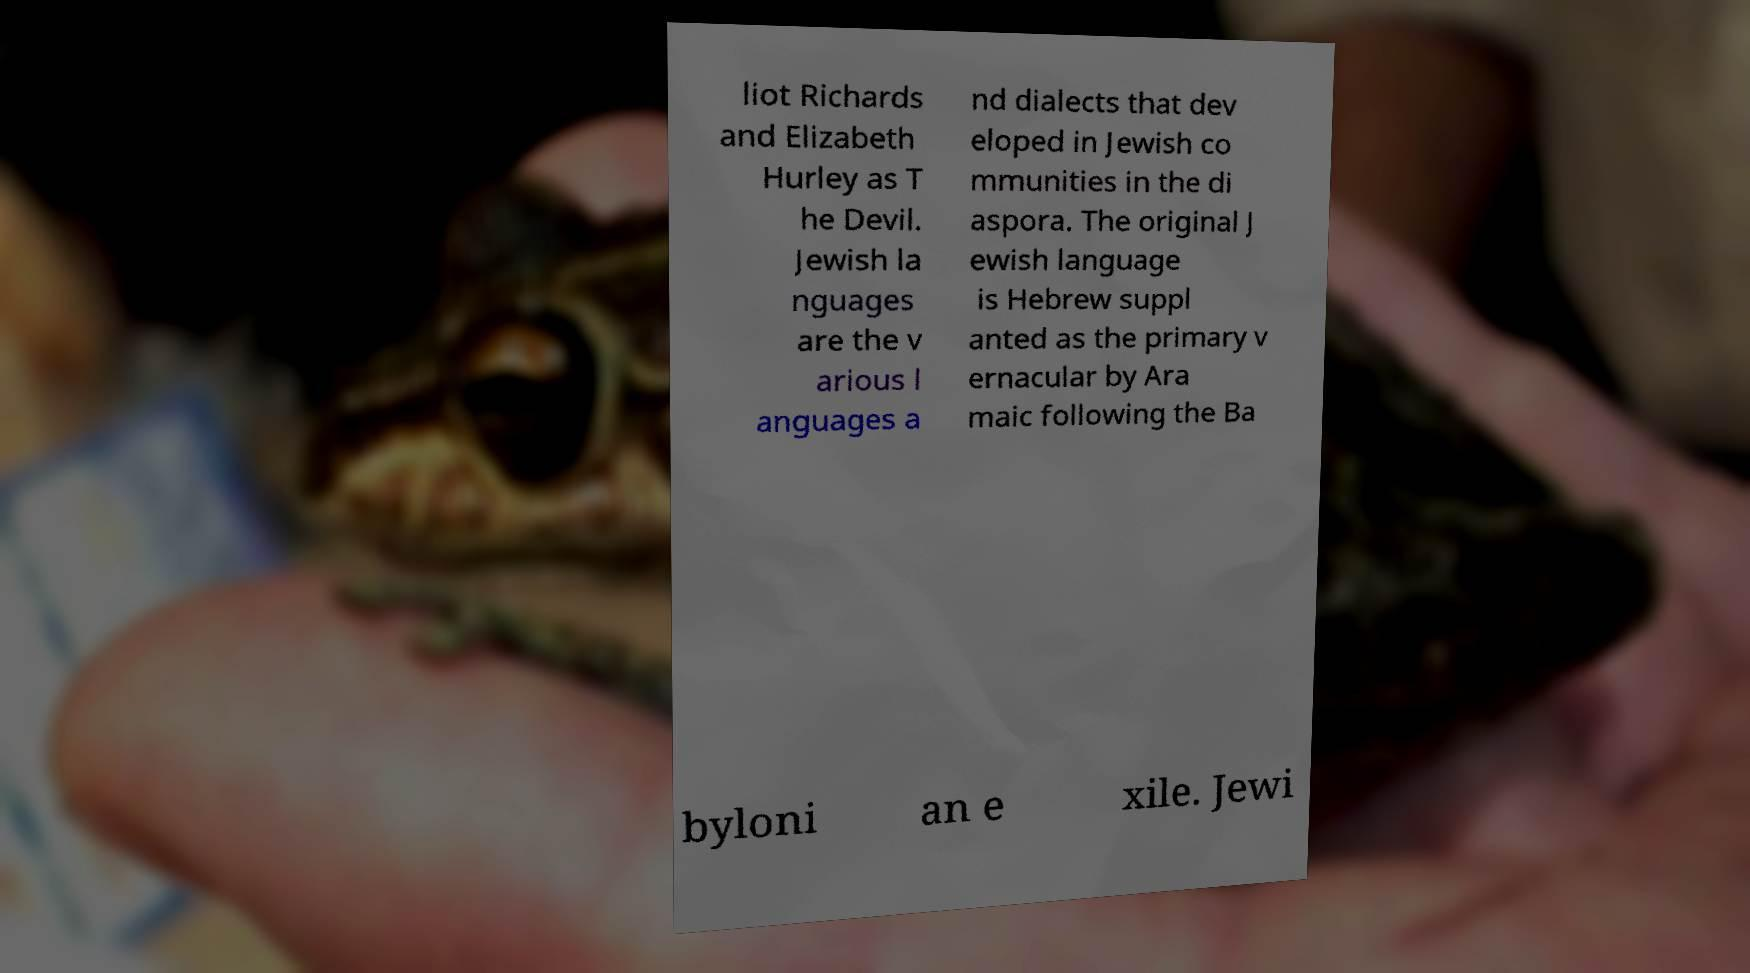What messages or text are displayed in this image? I need them in a readable, typed format. liot Richards and Elizabeth Hurley as T he Devil. Jewish la nguages are the v arious l anguages a nd dialects that dev eloped in Jewish co mmunities in the di aspora. The original J ewish language is Hebrew suppl anted as the primary v ernacular by Ara maic following the Ba byloni an e xile. Jewi 